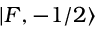Convert formula to latex. <formula><loc_0><loc_0><loc_500><loc_500>| F , - 1 / 2 \rangle</formula> 